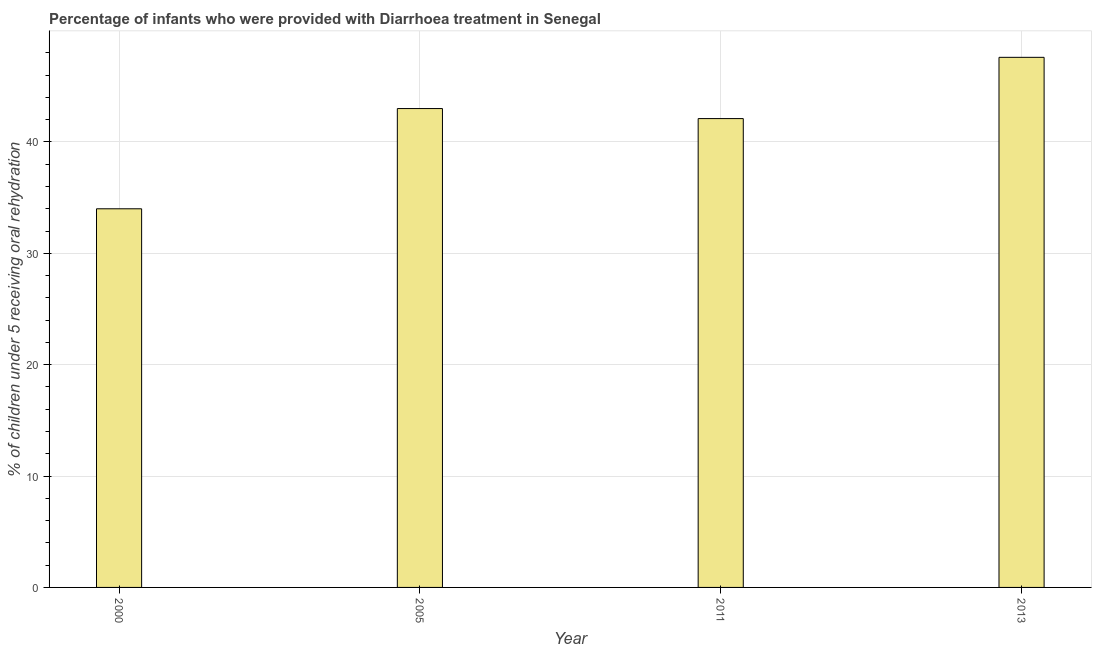Does the graph contain any zero values?
Give a very brief answer. No. Does the graph contain grids?
Provide a succinct answer. Yes. What is the title of the graph?
Your answer should be compact. Percentage of infants who were provided with Diarrhoea treatment in Senegal. What is the label or title of the Y-axis?
Your answer should be compact. % of children under 5 receiving oral rehydration. What is the percentage of children who were provided with treatment diarrhoea in 2000?
Your answer should be very brief. 34. Across all years, what is the maximum percentage of children who were provided with treatment diarrhoea?
Make the answer very short. 47.6. Across all years, what is the minimum percentage of children who were provided with treatment diarrhoea?
Ensure brevity in your answer.  34. In which year was the percentage of children who were provided with treatment diarrhoea maximum?
Provide a short and direct response. 2013. In which year was the percentage of children who were provided with treatment diarrhoea minimum?
Offer a terse response. 2000. What is the sum of the percentage of children who were provided with treatment diarrhoea?
Your answer should be very brief. 166.7. What is the average percentage of children who were provided with treatment diarrhoea per year?
Make the answer very short. 41.67. What is the median percentage of children who were provided with treatment diarrhoea?
Your response must be concise. 42.55. In how many years, is the percentage of children who were provided with treatment diarrhoea greater than 20 %?
Your answer should be very brief. 4. Do a majority of the years between 2013 and 2005 (inclusive) have percentage of children who were provided with treatment diarrhoea greater than 20 %?
Keep it short and to the point. Yes. What is the ratio of the percentage of children who were provided with treatment diarrhoea in 2011 to that in 2013?
Keep it short and to the point. 0.88. Is the percentage of children who were provided with treatment diarrhoea in 2000 less than that in 2011?
Offer a terse response. Yes. Is the difference between the percentage of children who were provided with treatment diarrhoea in 2005 and 2013 greater than the difference between any two years?
Make the answer very short. No. What is the difference between the highest and the second highest percentage of children who were provided with treatment diarrhoea?
Offer a very short reply. 4.6. Is the sum of the percentage of children who were provided with treatment diarrhoea in 2005 and 2011 greater than the maximum percentage of children who were provided with treatment diarrhoea across all years?
Keep it short and to the point. Yes. Are all the bars in the graph horizontal?
Offer a terse response. No. How many years are there in the graph?
Ensure brevity in your answer.  4. Are the values on the major ticks of Y-axis written in scientific E-notation?
Your answer should be compact. No. What is the % of children under 5 receiving oral rehydration of 2000?
Your answer should be compact. 34. What is the % of children under 5 receiving oral rehydration in 2011?
Your response must be concise. 42.1. What is the % of children under 5 receiving oral rehydration in 2013?
Ensure brevity in your answer.  47.6. What is the difference between the % of children under 5 receiving oral rehydration in 2000 and 2013?
Keep it short and to the point. -13.6. What is the difference between the % of children under 5 receiving oral rehydration in 2005 and 2011?
Provide a short and direct response. 0.9. What is the difference between the % of children under 5 receiving oral rehydration in 2005 and 2013?
Offer a very short reply. -4.6. What is the ratio of the % of children under 5 receiving oral rehydration in 2000 to that in 2005?
Your answer should be very brief. 0.79. What is the ratio of the % of children under 5 receiving oral rehydration in 2000 to that in 2011?
Offer a terse response. 0.81. What is the ratio of the % of children under 5 receiving oral rehydration in 2000 to that in 2013?
Provide a succinct answer. 0.71. What is the ratio of the % of children under 5 receiving oral rehydration in 2005 to that in 2011?
Ensure brevity in your answer.  1.02. What is the ratio of the % of children under 5 receiving oral rehydration in 2005 to that in 2013?
Your answer should be compact. 0.9. What is the ratio of the % of children under 5 receiving oral rehydration in 2011 to that in 2013?
Ensure brevity in your answer.  0.88. 